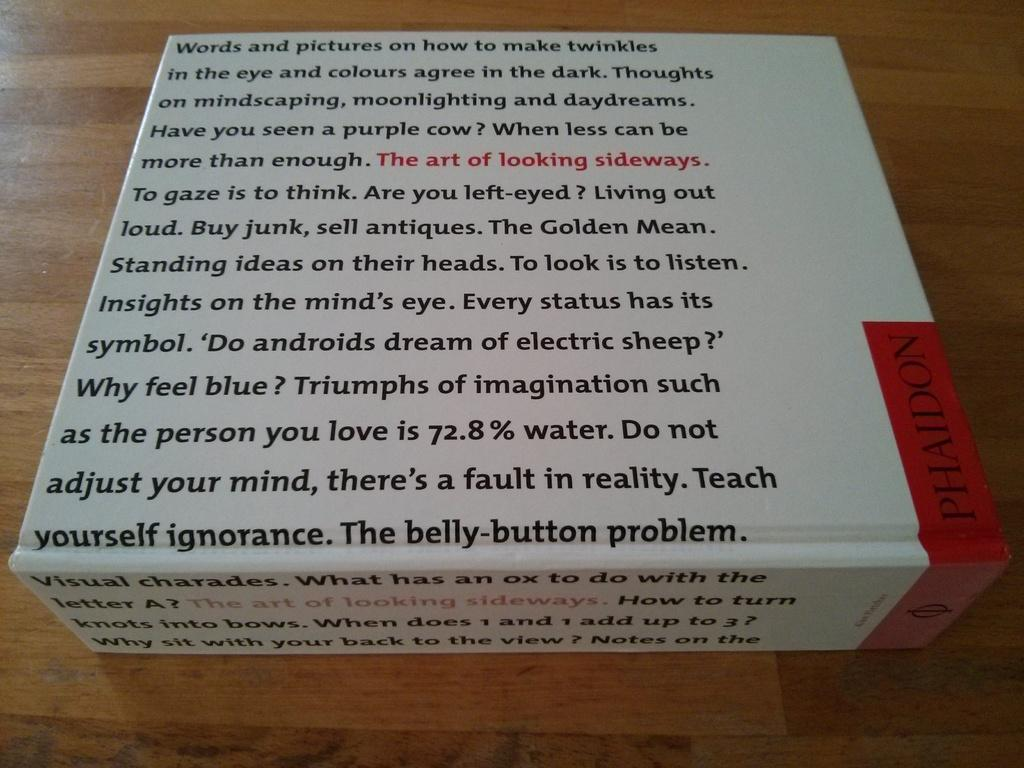<image>
Give a short and clear explanation of the subsequent image. A box with text all over it including the sentence, "The Belly-button Problem." 